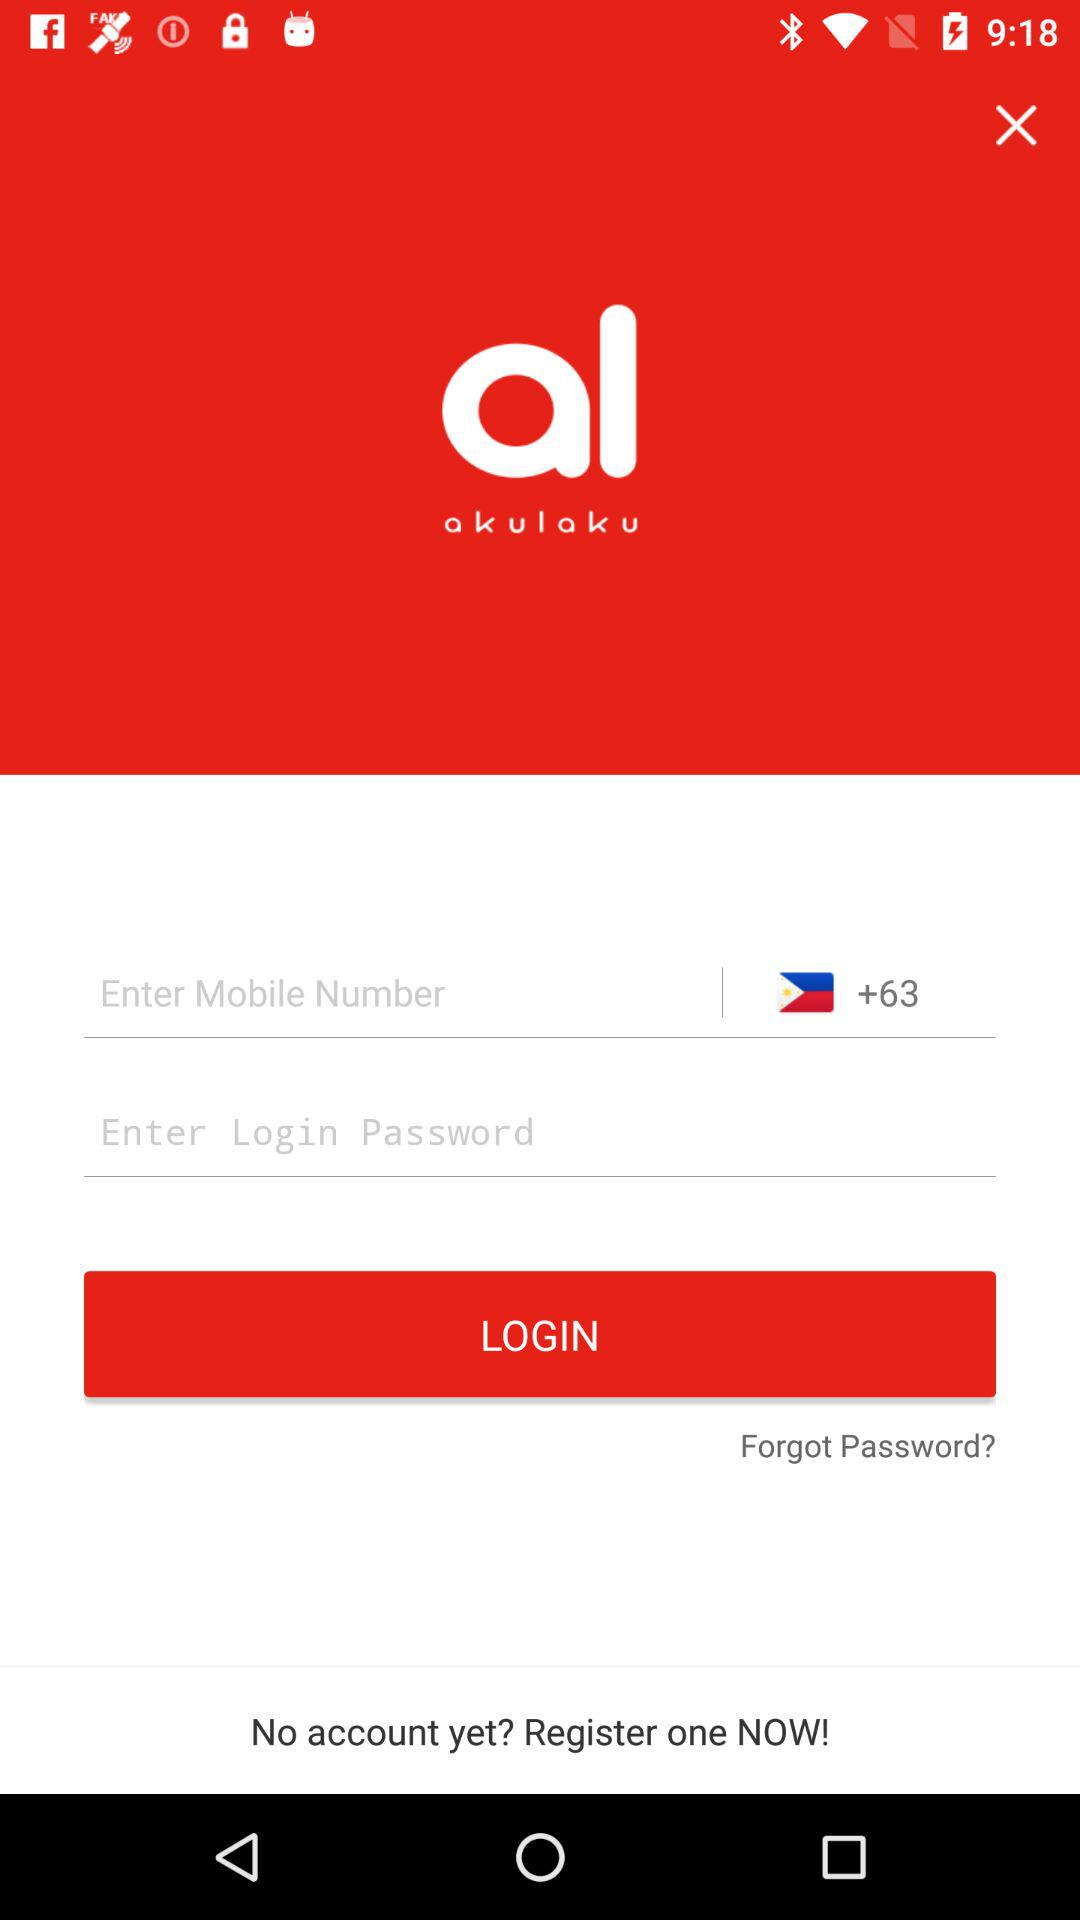What is the country code shown on the screen? The country code shown on the screen is +63. 